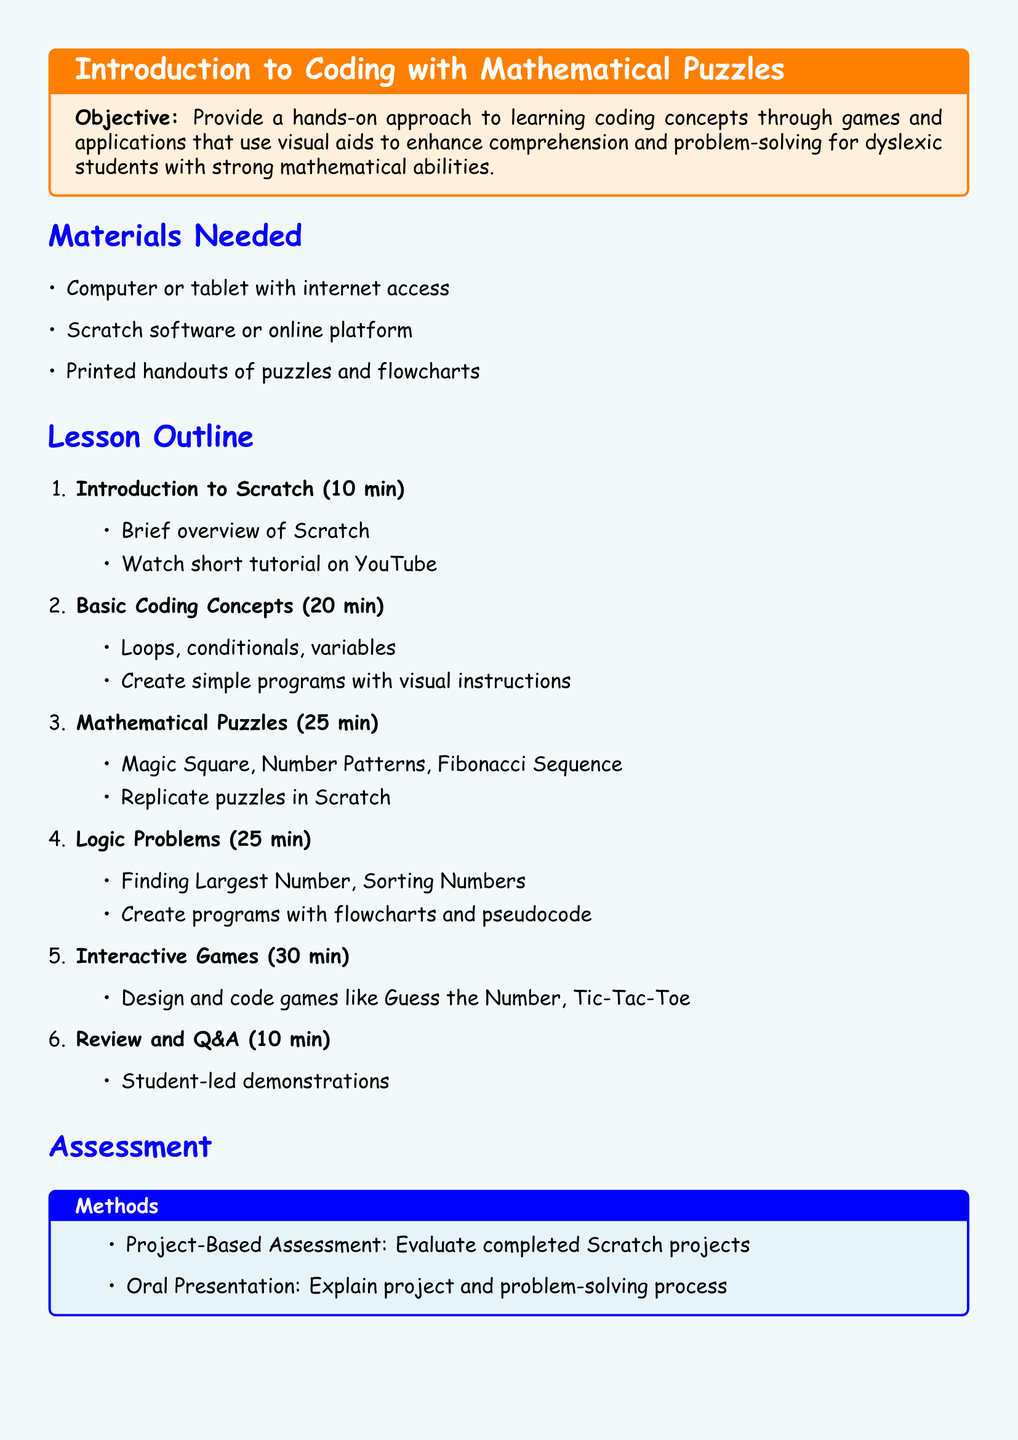What is the objective of the lesson? The objective is to provide a hands-on approach to learning coding concepts through games and applications that use visual aids to enhance comprehension and problem-solving for dyslexic students with strong mathematical abilities.
Answer: Hands-on approach to learning coding concepts What software is used in the lesson? The lesson mentions the software used, which is for creating and coding projects visually.
Answer: Scratch How long is the introduction to Scratch? The introduction to Scratch is scheduled for a brief period in the lesson plan.
Answer: 10 min What types of puzzles are included in the lesson? The lesson outlines specific mathematical puzzles and codes that will be worked on.
Answer: Magic Square, Number Patterns, Fibonacci Sequence What is the main assessment method described in the document? The assessment method focuses on the evaluation of projects students create using the coding platform.
Answer: Project-Based Assessment How many minutes are allocated for interactive games? The time scheduled for designing and coding games is specified in the lesson.
Answer: 30 min What criteria are used for assessment? The document lists key factors that will be evaluated through student projects and presentations.
Answer: Understanding of coding concepts What type of resources are provided at the end of the lesson plan? Various online platforms and materials are mentioned as resources for further learning and exploration.
Answer: Additional Resources What is one of the logic problems students will solve? The lesson plan includes specific logic problems that students will tackle using coding methods.
Answer: Finding Largest Number 